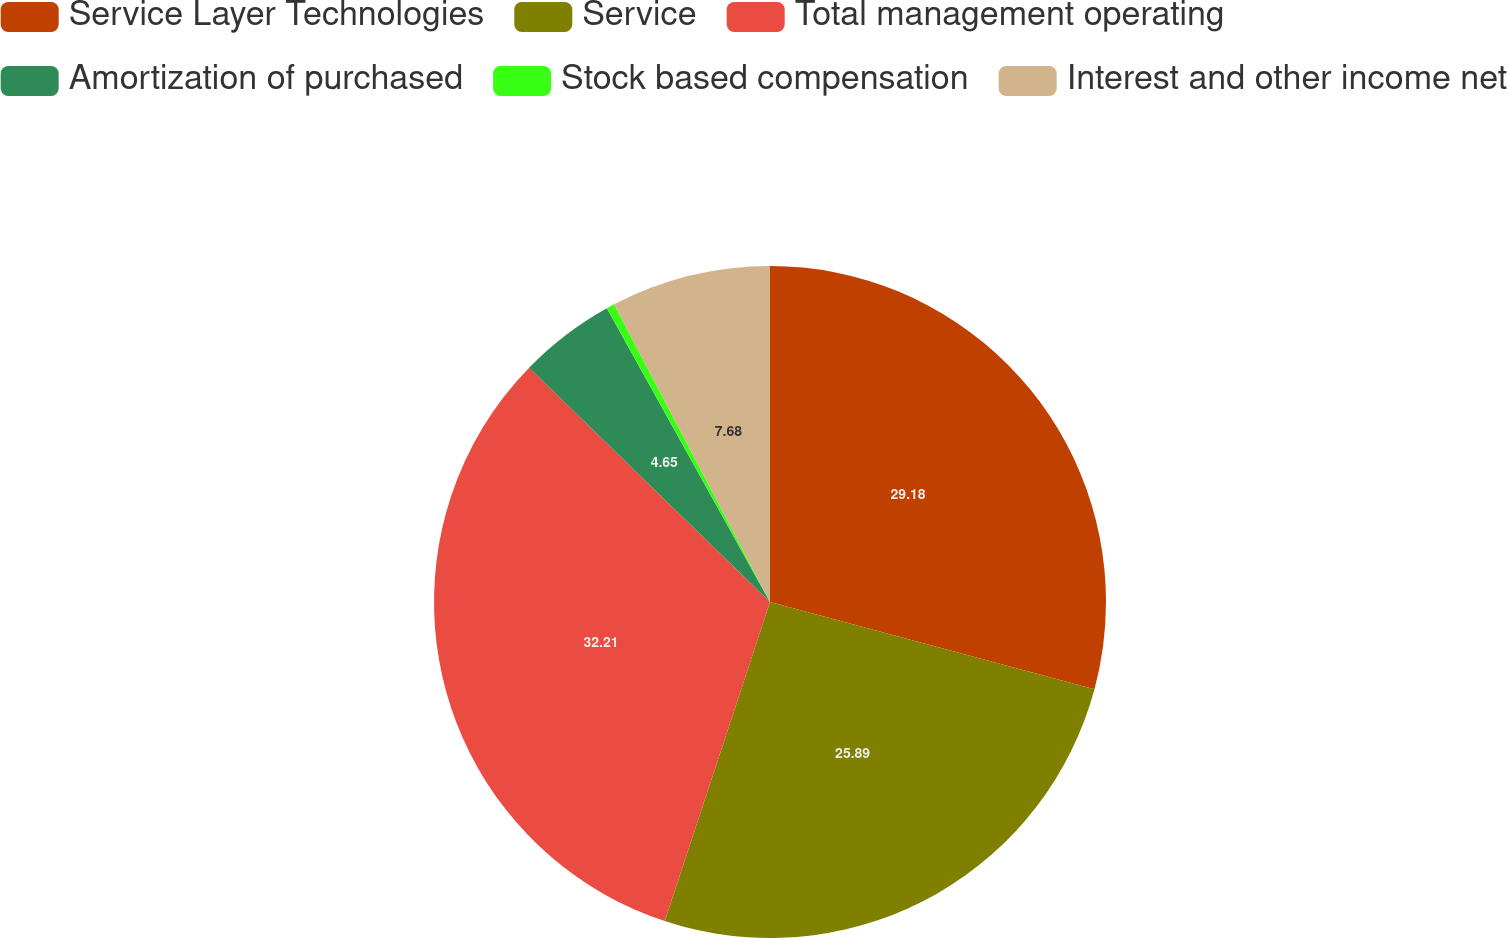<chart> <loc_0><loc_0><loc_500><loc_500><pie_chart><fcel>Service Layer Technologies<fcel>Service<fcel>Total management operating<fcel>Amortization of purchased<fcel>Stock based compensation<fcel>Interest and other income net<nl><fcel>29.18%<fcel>25.89%<fcel>32.21%<fcel>4.65%<fcel>0.39%<fcel>7.68%<nl></chart> 